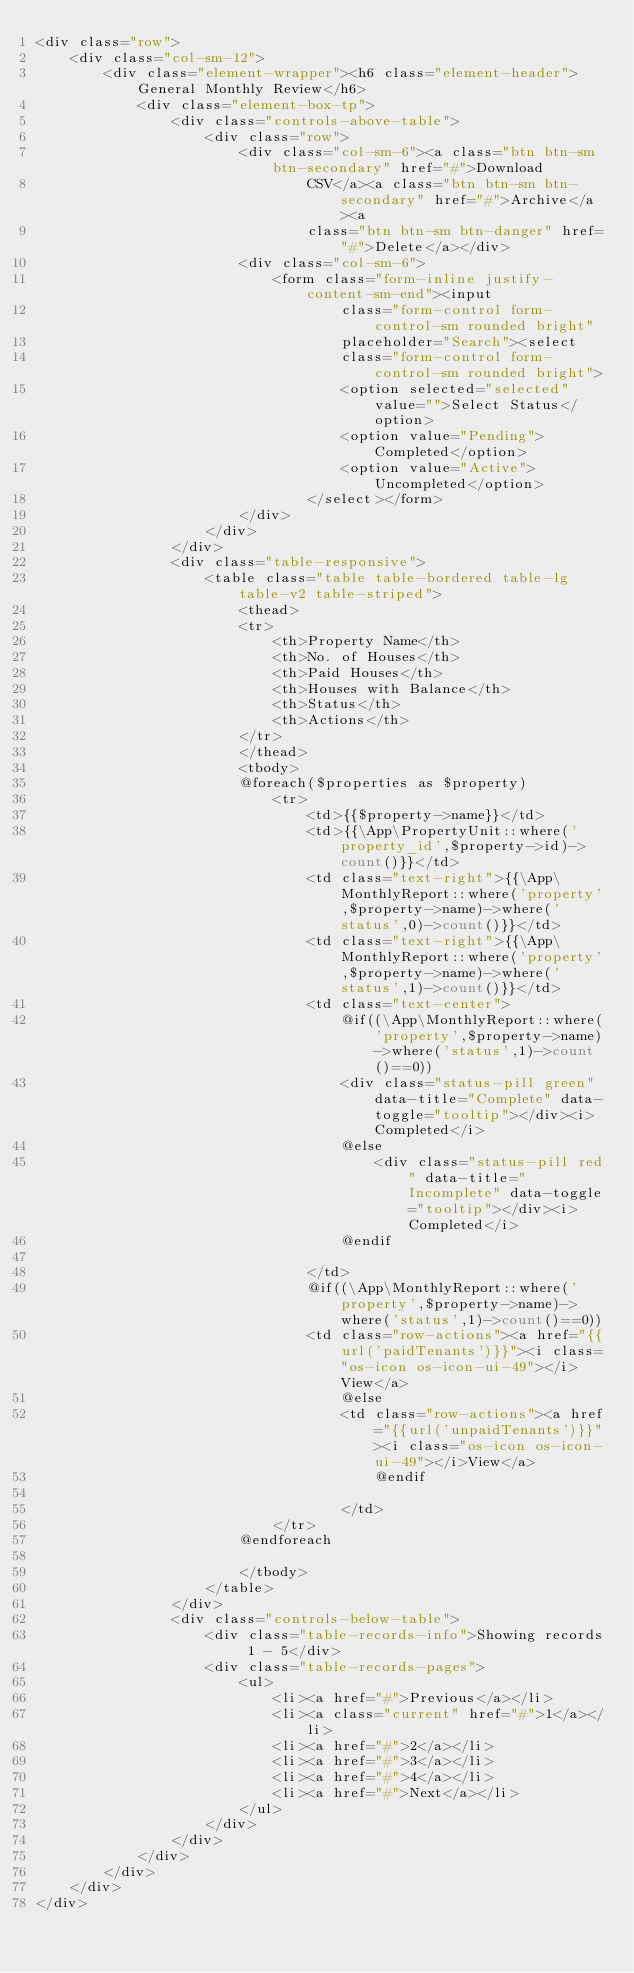Convert code to text. <code><loc_0><loc_0><loc_500><loc_500><_PHP_><div class="row">
    <div class="col-sm-12">
        <div class="element-wrapper"><h6 class="element-header">General Monthly Review</h6>
            <div class="element-box-tp">
                <div class="controls-above-table">
                    <div class="row">
                        <div class="col-sm-6"><a class="btn btn-sm btn-secondary" href="#">Download
                                CSV</a><a class="btn btn-sm btn-secondary" href="#">Archive</a><a
                                class="btn btn-sm btn-danger" href="#">Delete</a></div>
                        <div class="col-sm-6">
                            <form class="form-inline justify-content-sm-end"><input
                                    class="form-control form-control-sm rounded bright"
                                    placeholder="Search"><select
                                    class="form-control form-control-sm rounded bright">
                                    <option selected="selected" value="">Select Status</option>
                                    <option value="Pending">Completed</option>
                                    <option value="Active">Uncompleted</option>
                                </select></form>
                        </div>
                    </div>
                </div>
                <div class="table-responsive">
                    <table class="table table-bordered table-lg table-v2 table-striped">
                        <thead>
                        <tr>
                            <th>Property Name</th>
                            <th>No. of Houses</th>
                            <th>Paid Houses</th>
                            <th>Houses with Balance</th>
                            <th>Status</th>
                            <th>Actions</th>
                        </tr>
                        </thead>
                        <tbody>
                        @foreach($properties as $property)
                            <tr>
                                <td>{{$property->name}}</td>
                                <td>{{\App\PropertyUnit::where('property_id',$property->id)->count()}}</td>
                                <td class="text-right">{{\App\MonthlyReport::where('property',$property->name)->where('status',0)->count()}}</td>
                                <td class="text-right">{{\App\MonthlyReport::where('property',$property->name)->where('status',1)->count()}}</td>
                                <td class="text-center">
                                    @if((\App\MonthlyReport::where('property',$property->name)->where('status',1)->count()==0))
                                    <div class="status-pill green" data-title="Complete" data-toggle="tooltip"></div><i>Completed</i>
                                    @else
                                        <div class="status-pill red" data-title="Incomplete" data-toggle="tooltip"></div><i>Completed</i>
                                    @endif

                                </td>
                                @if((\App\MonthlyReport::where('property',$property->name)->where('status',1)->count()==0))
                                <td class="row-actions"><a href="{{url('paidTenants')}}"><i class="os-icon os-icon-ui-49"></i>View</a>
                                    @else
                                    <td class="row-actions"><a href="{{url('unpaidTenants')}}"><i class="os-icon os-icon-ui-49"></i>View</a>
                                        @endif

                                    </td>
                            </tr>
                        @endforeach

                        </tbody>
                    </table>
                </div>
                <div class="controls-below-table">
                    <div class="table-records-info">Showing records 1 - 5</div>
                    <div class="table-records-pages">
                        <ul>
                            <li><a href="#">Previous</a></li>
                            <li><a class="current" href="#">1</a></li>
                            <li><a href="#">2</a></li>
                            <li><a href="#">3</a></li>
                            <li><a href="#">4</a></li>
                            <li><a href="#">Next</a></li>
                        </ul>
                    </div>
                </div>
            </div>
        </div>
    </div>
</div>
</code> 